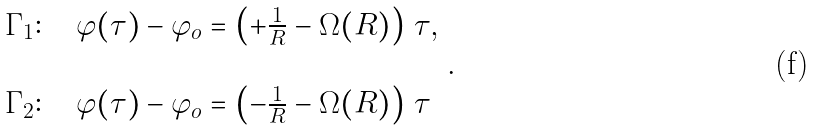<formula> <loc_0><loc_0><loc_500><loc_500>\begin{array} { l } \Gamma _ { 1 } \colon \quad \varphi ( \tau ) - \varphi _ { o } = \left ( + \frac { 1 } { R } - \Omega ( R ) \right ) \, \tau , \\ \\ \Gamma _ { 2 } \colon \quad \varphi ( \tau ) - \varphi _ { o } = \left ( - \frac { 1 } { R } - \Omega ( R ) \right ) \, \tau \end{array} .</formula> 